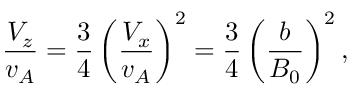<formula> <loc_0><loc_0><loc_500><loc_500>\frac { V _ { z } } { v _ { A } } = \frac { 3 } { 4 } \left ( \frac { V _ { x } } { v _ { A } } \right ) ^ { 2 } = \frac { 3 } { 4 } \left ( \frac { b } { B _ { 0 } } \right ) ^ { 2 } ,</formula> 